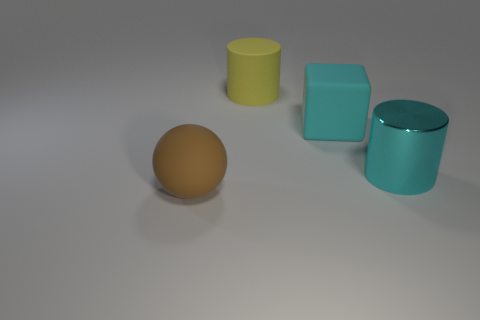Add 3 big yellow rubber things. How many objects exist? 7 Subtract all yellow cylinders. How many cylinders are left? 1 Subtract all spheres. How many objects are left? 3 Subtract all small green shiny cubes. Subtract all large rubber things. How many objects are left? 1 Add 2 matte cylinders. How many matte cylinders are left? 3 Add 1 big brown matte balls. How many big brown matte balls exist? 2 Subtract 0 red cylinders. How many objects are left? 4 Subtract 1 cylinders. How many cylinders are left? 1 Subtract all red spheres. Subtract all purple cubes. How many spheres are left? 1 Subtract all cyan spheres. How many red cylinders are left? 0 